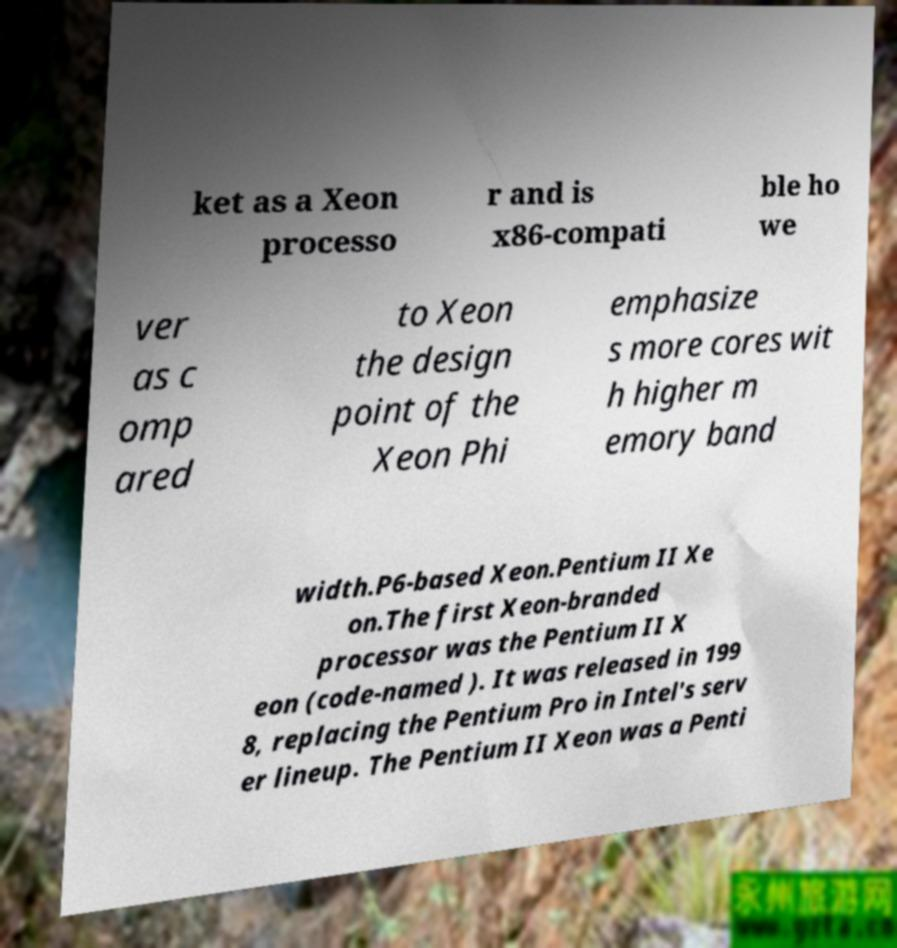I need the written content from this picture converted into text. Can you do that? ket as a Xeon processo r and is x86-compati ble ho we ver as c omp ared to Xeon the design point of the Xeon Phi emphasize s more cores wit h higher m emory band width.P6-based Xeon.Pentium II Xe on.The first Xeon-branded processor was the Pentium II X eon (code-named ). It was released in 199 8, replacing the Pentium Pro in Intel's serv er lineup. The Pentium II Xeon was a Penti 